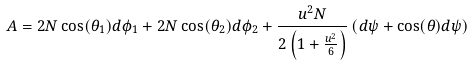<formula> <loc_0><loc_0><loc_500><loc_500>A = 2 N \cos ( \theta _ { 1 } ) d \phi _ { 1 } + 2 N \cos ( \theta _ { 2 } ) d \phi _ { 2 } + \frac { u ^ { 2 } N } { 2 \left ( 1 + \frac { u ^ { 2 } } { 6 } \right ) } \left ( d \psi + \cos ( \theta ) d \psi \right )</formula> 